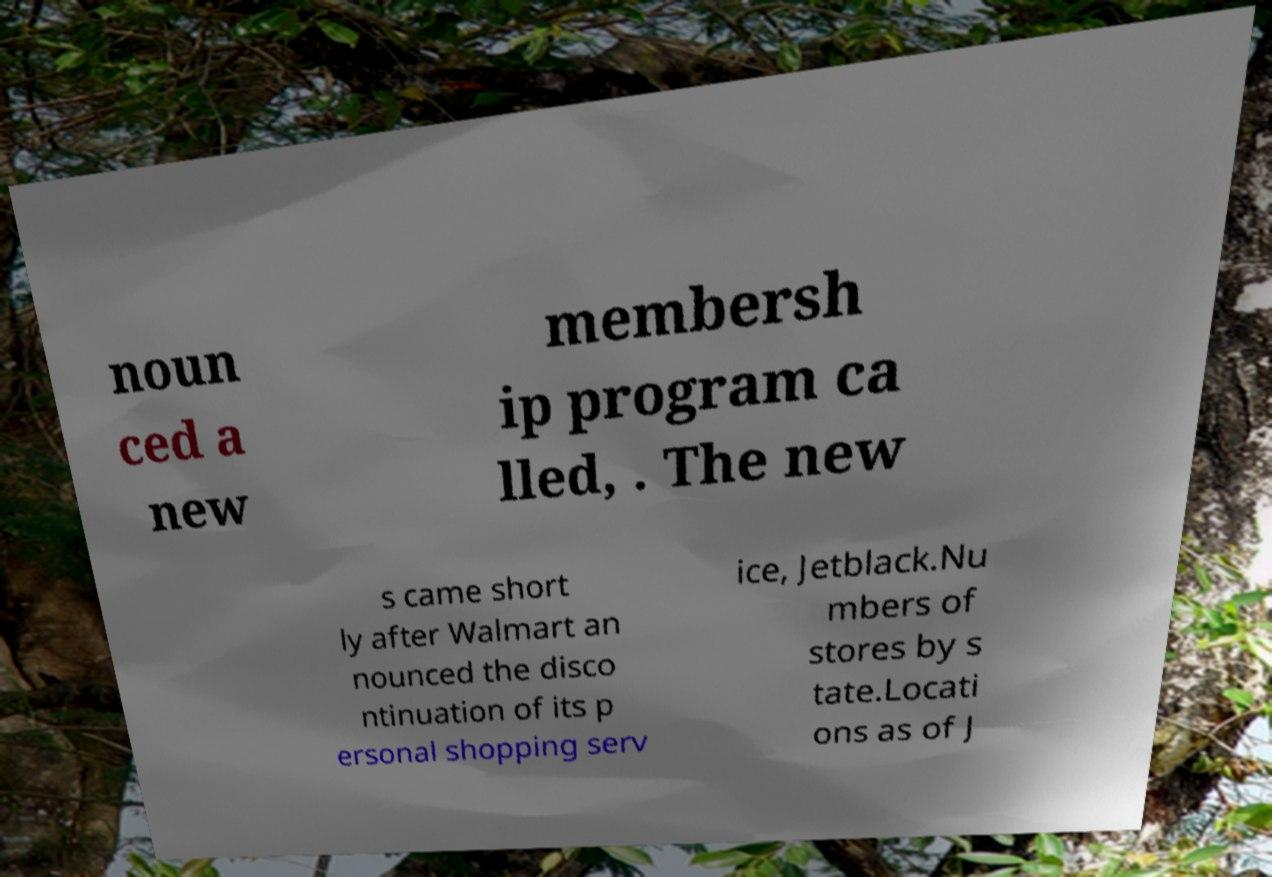What messages or text are displayed in this image? I need them in a readable, typed format. noun ced a new membersh ip program ca lled, . The new s came short ly after Walmart an nounced the disco ntinuation of its p ersonal shopping serv ice, Jetblack.Nu mbers of stores by s tate.Locati ons as of J 